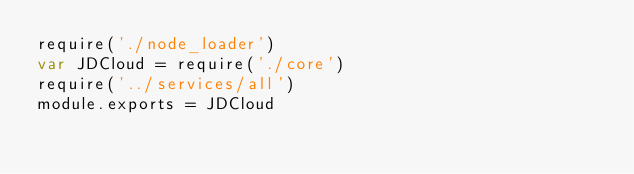Convert code to text. <code><loc_0><loc_0><loc_500><loc_500><_JavaScript_>require('./node_loader')
var JDCloud = require('./core')
require('../services/all')
module.exports = JDCloud
</code> 